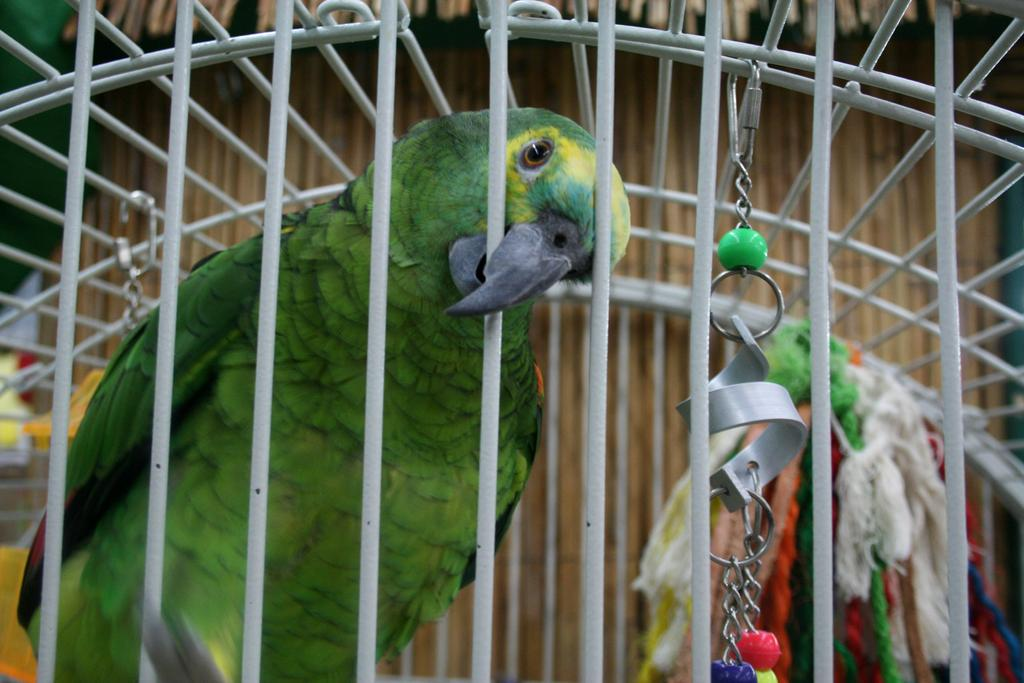What type of animal is in the image? There is a parrot in the image. Where is the parrot located? The parrot is in a cage. What type of pipe is the parrot using to create trouble in the image? There is no pipe present in the image, and the parrot is not creating any trouble. 